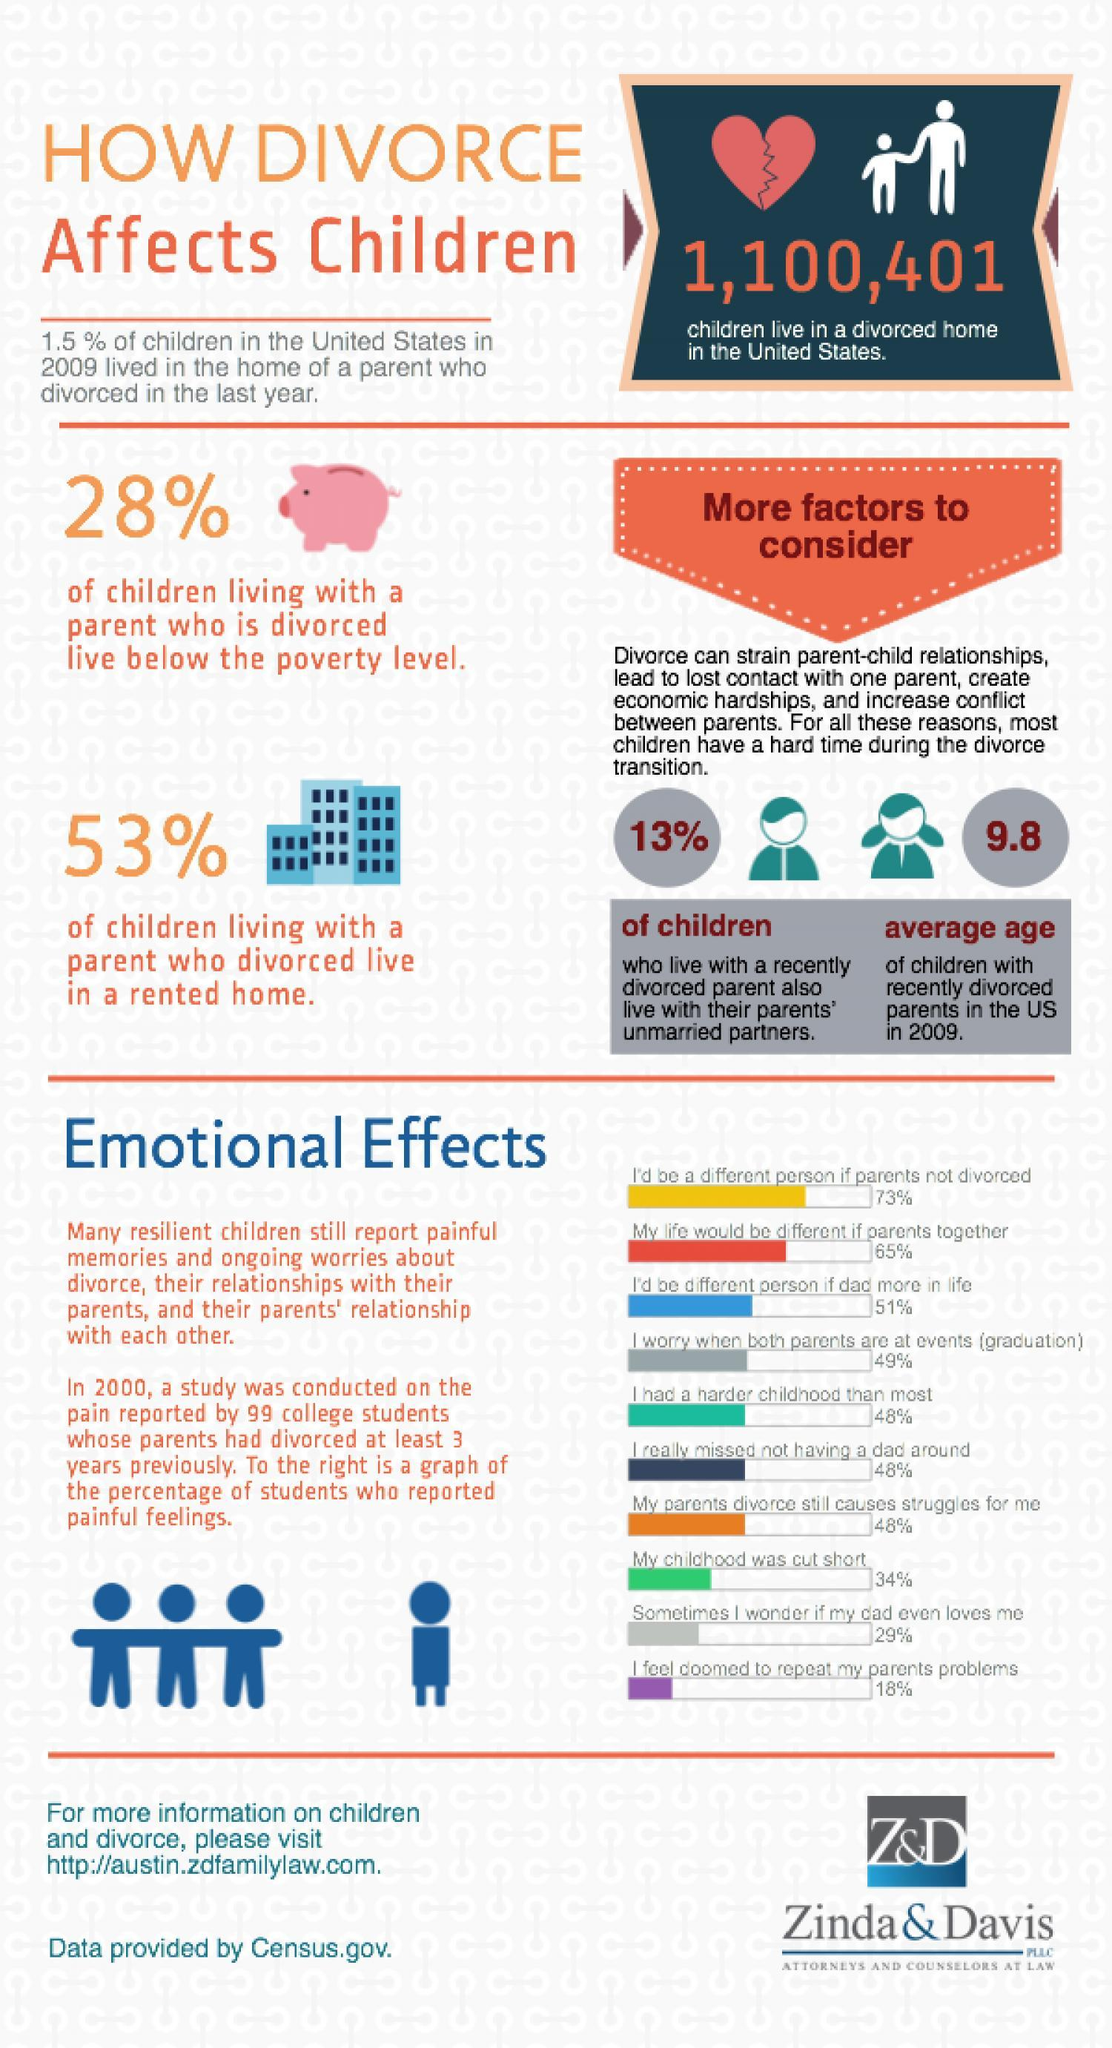What percentage of children living with a parent who divorced live in their own home?
Answer the question with a short phrase. 47% What percentage of children living with a parent who is divorced live above the poverty level? 72% 